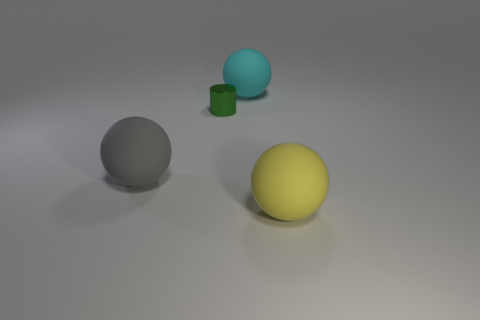Add 1 large gray shiny balls. How many objects exist? 5 Subtract all spheres. How many objects are left? 1 Subtract all brown cubes. Subtract all small green metal cylinders. How many objects are left? 3 Add 2 cyan spheres. How many cyan spheres are left? 3 Add 2 large yellow balls. How many large yellow balls exist? 3 Subtract 0 red blocks. How many objects are left? 4 